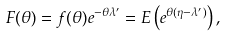Convert formula to latex. <formula><loc_0><loc_0><loc_500><loc_500>F ( \theta ) = f ( \theta ) e ^ { - \theta \lambda ^ { \prime } } = E \left ( e ^ { \theta ( \eta - \lambda ^ { \prime } ) } \right ) ,</formula> 